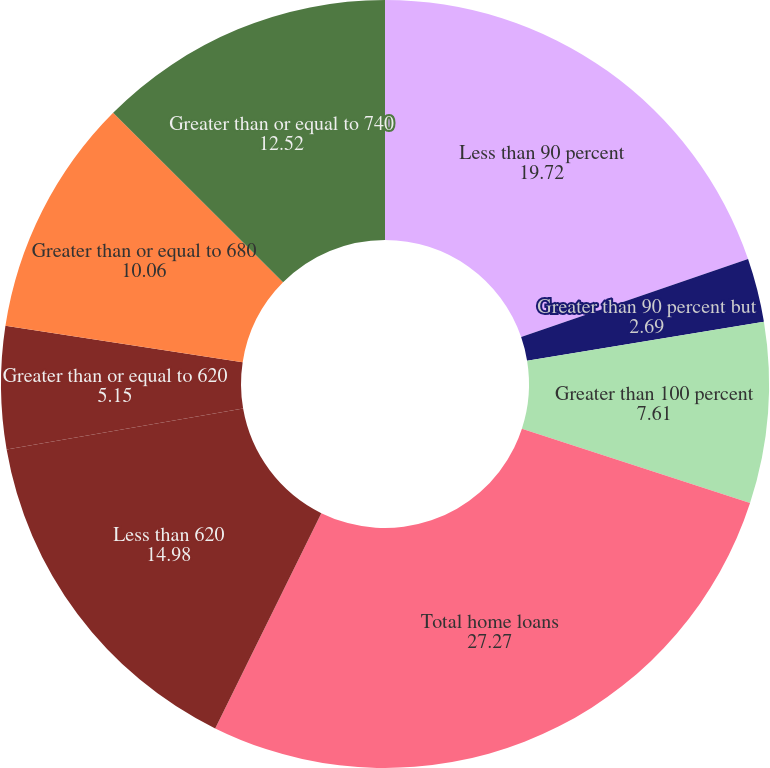Convert chart to OTSL. <chart><loc_0><loc_0><loc_500><loc_500><pie_chart><fcel>Less than 90 percent<fcel>Greater than 90 percent but<fcel>Greater than 100 percent<fcel>Total home loans<fcel>Less than 620<fcel>Greater than or equal to 620<fcel>Greater than or equal to 680<fcel>Greater than or equal to 740<nl><fcel>19.72%<fcel>2.69%<fcel>7.61%<fcel>27.27%<fcel>14.98%<fcel>5.15%<fcel>10.06%<fcel>12.52%<nl></chart> 